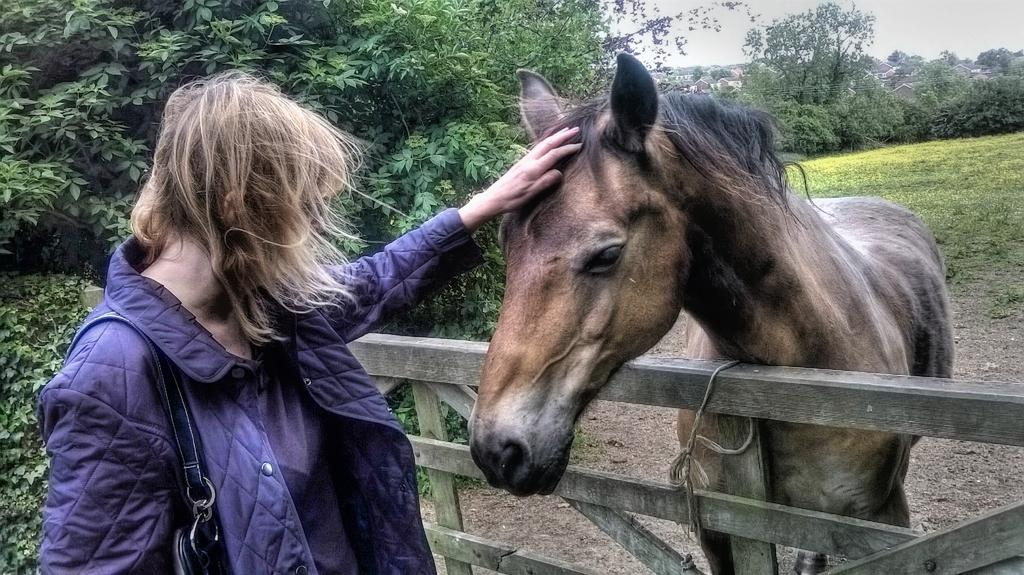Who is present in the image? There is a woman in the image. What is the woman wearing? The woman is wearing a blue jerkin. What is the woman carrying? The woman is carrying a handbag. What animal is in the image? There is a horse in the image. What type of structure is in the image? There is a wooden gate in the image. What can be seen in the background of the image? There are trees and grass visible in the background of the image. What type of jelly can be seen on the horse's back in the image? There is no jelly present on the horse's back in the image. Is there a car visible in the image? No, there is no car present in the image. 